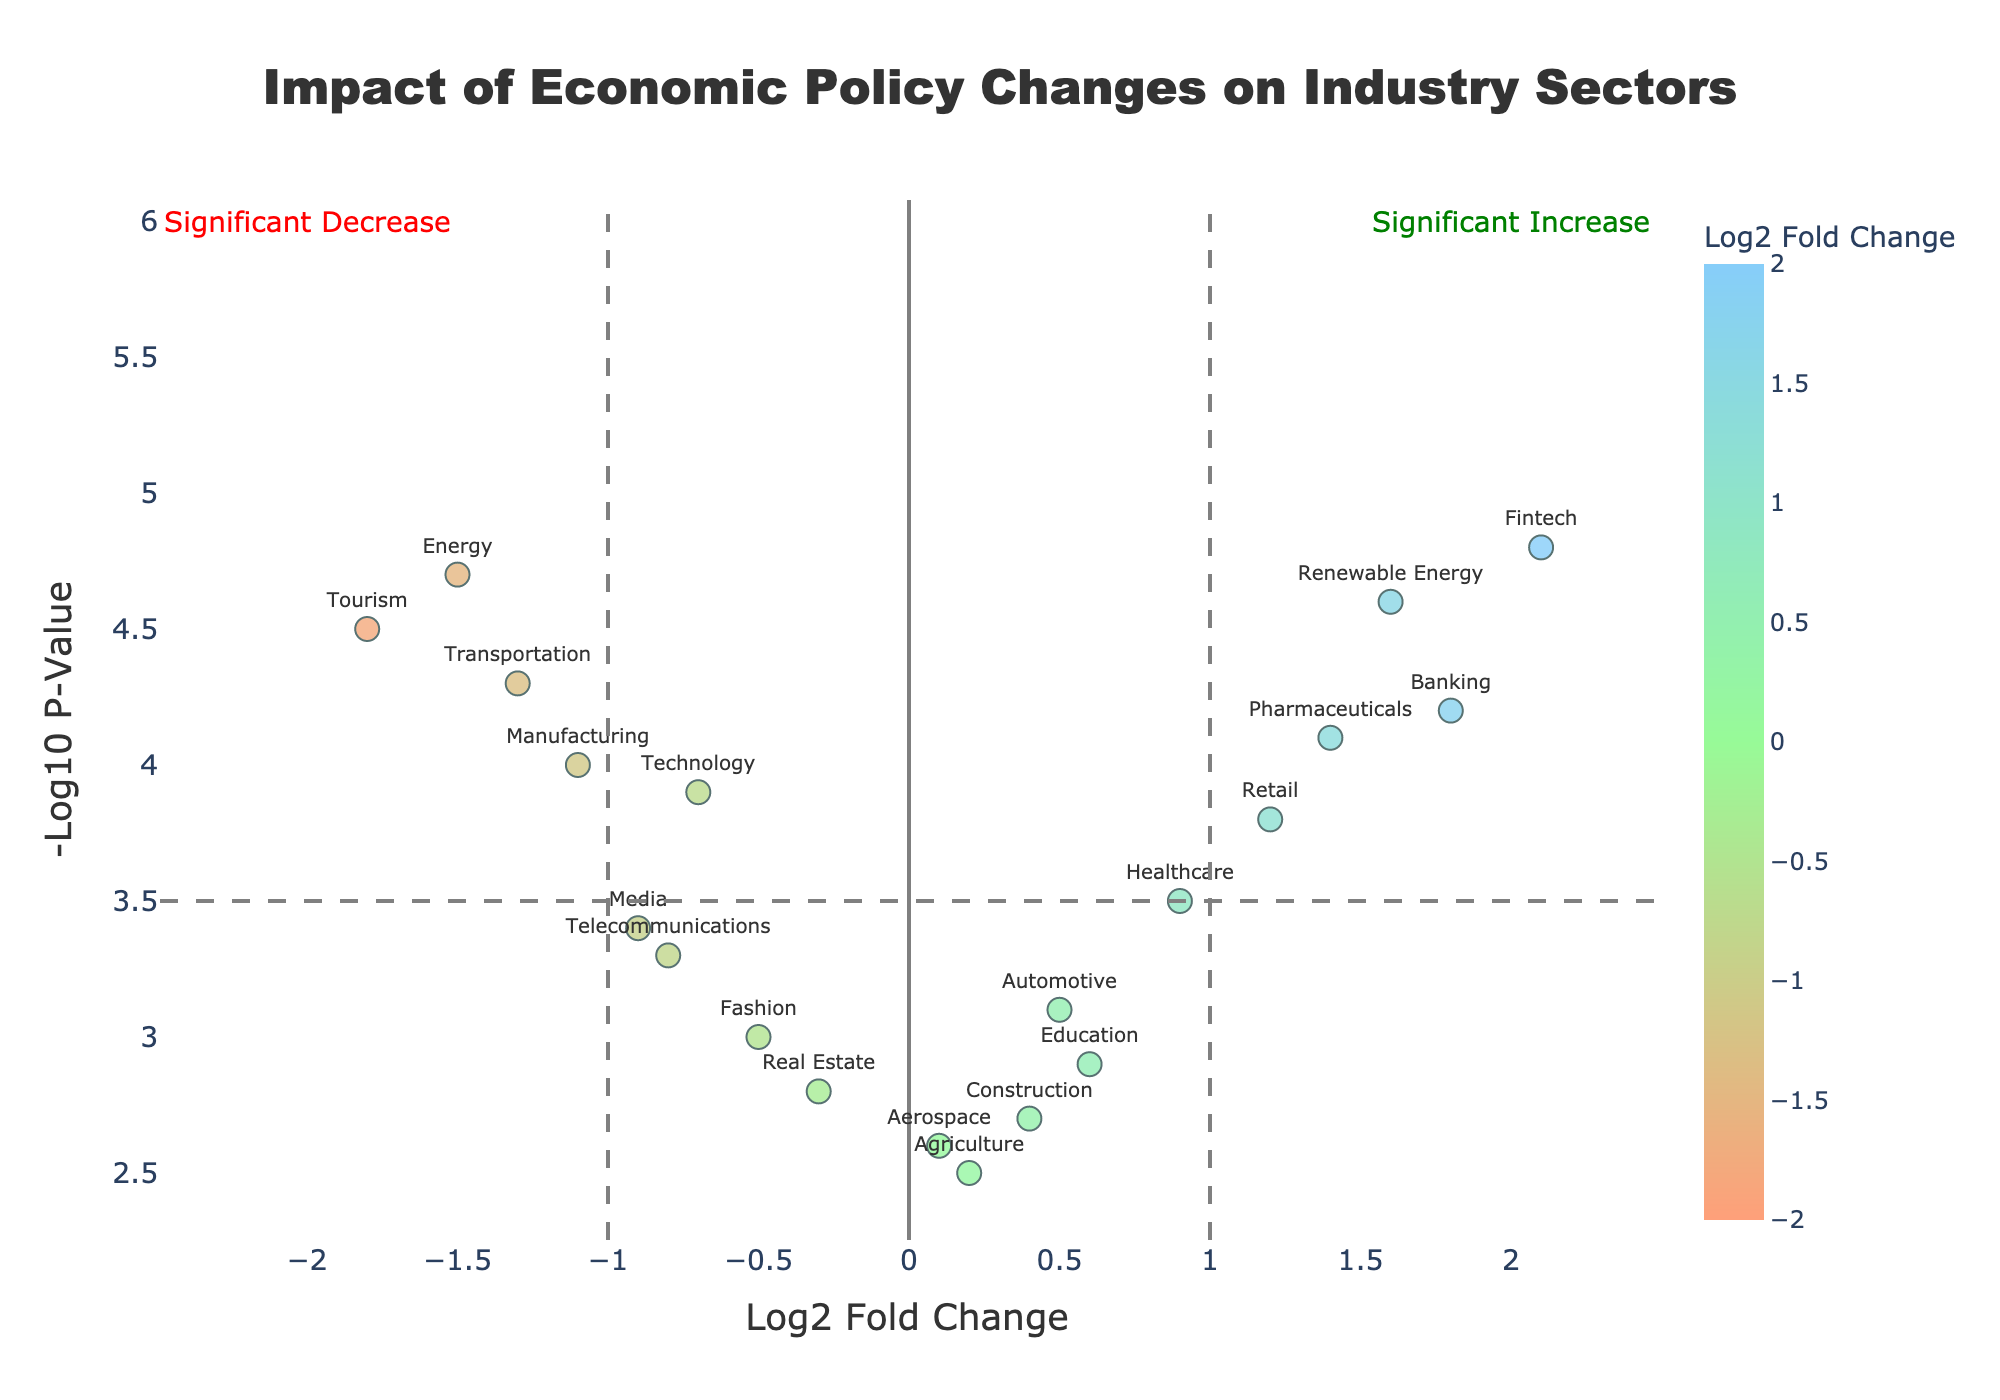How many sectors show a significant increase in their impact due to economic policy changes? The plot has a vertical line for the fold change threshold at Log2 Fold Change = 1 and a horizontal line for the p-value threshold at -Log10 P-Value = 3.5. Check how many data points are in the top right quadrant, which indicates a significant increase. Realistically, this would be sectors with Log2 Fold Change > 1 and -Log10 P-Value > 3.5. The sectors are Banking, Renewable Energy, Pharmaceuticals, and Fintech.
Answer: 4 Which sector exhibits the most significant decrease in impact? To determine the most significant decrease, look for the sector with the lowest Log2 Fold Change and highest -Log10 P-Value in the lower-left quadrant. Tourism has a Log2 Fold Change of -1.8 and a NegativeLogPValue of 4.5, which is the most significant decrease.
Answer: Tourism What is the Log2 Fold Change for the Healthcare sector? Locate the sector 'Healthcare' on the plot and read off its Log2 Fold Change value, which is 0.9.
Answer: 0.9 Is there a sector with a Log2 Fold Change exactly equal to 2.0? Scan the plot to see if any data points lie exactly on the Log2 Fold Change = 2 line. Based on the given data, there are no sectors with Log2 Fold Change exactly equal to 2.
Answer: No Which sector has the highest -Log10 P-Value? Find the sector with the highest y-axis value, which represents the -Log10 P-Value. Fintech is at the topmost with a -Log10 P-Value of 4.8.
Answer: Fintech Which sector is the closest to the origin (Log2 Fold Change = 0, -Log10 P-Value = 0)? Check for the sector nearest to the vertical and horizontal zero lines. Aerospace, with Log2 Fold Change of 0.1 and -Log10 P-Value of 2.6, is closest to the origin.
Answer: Aerospace How many sectors have a negative Log2 Fold Change but do not cross the significance threshold for the -Log10 P-Value? Locate sectors on the left half of the plot (Log2 Fold Change < 0) that do not exceed the -Log10 P-Value of 3.5 threshold. The sectors are Technology, Real Estate, Telecommunications, Fashion, and Media.
Answer: 5 